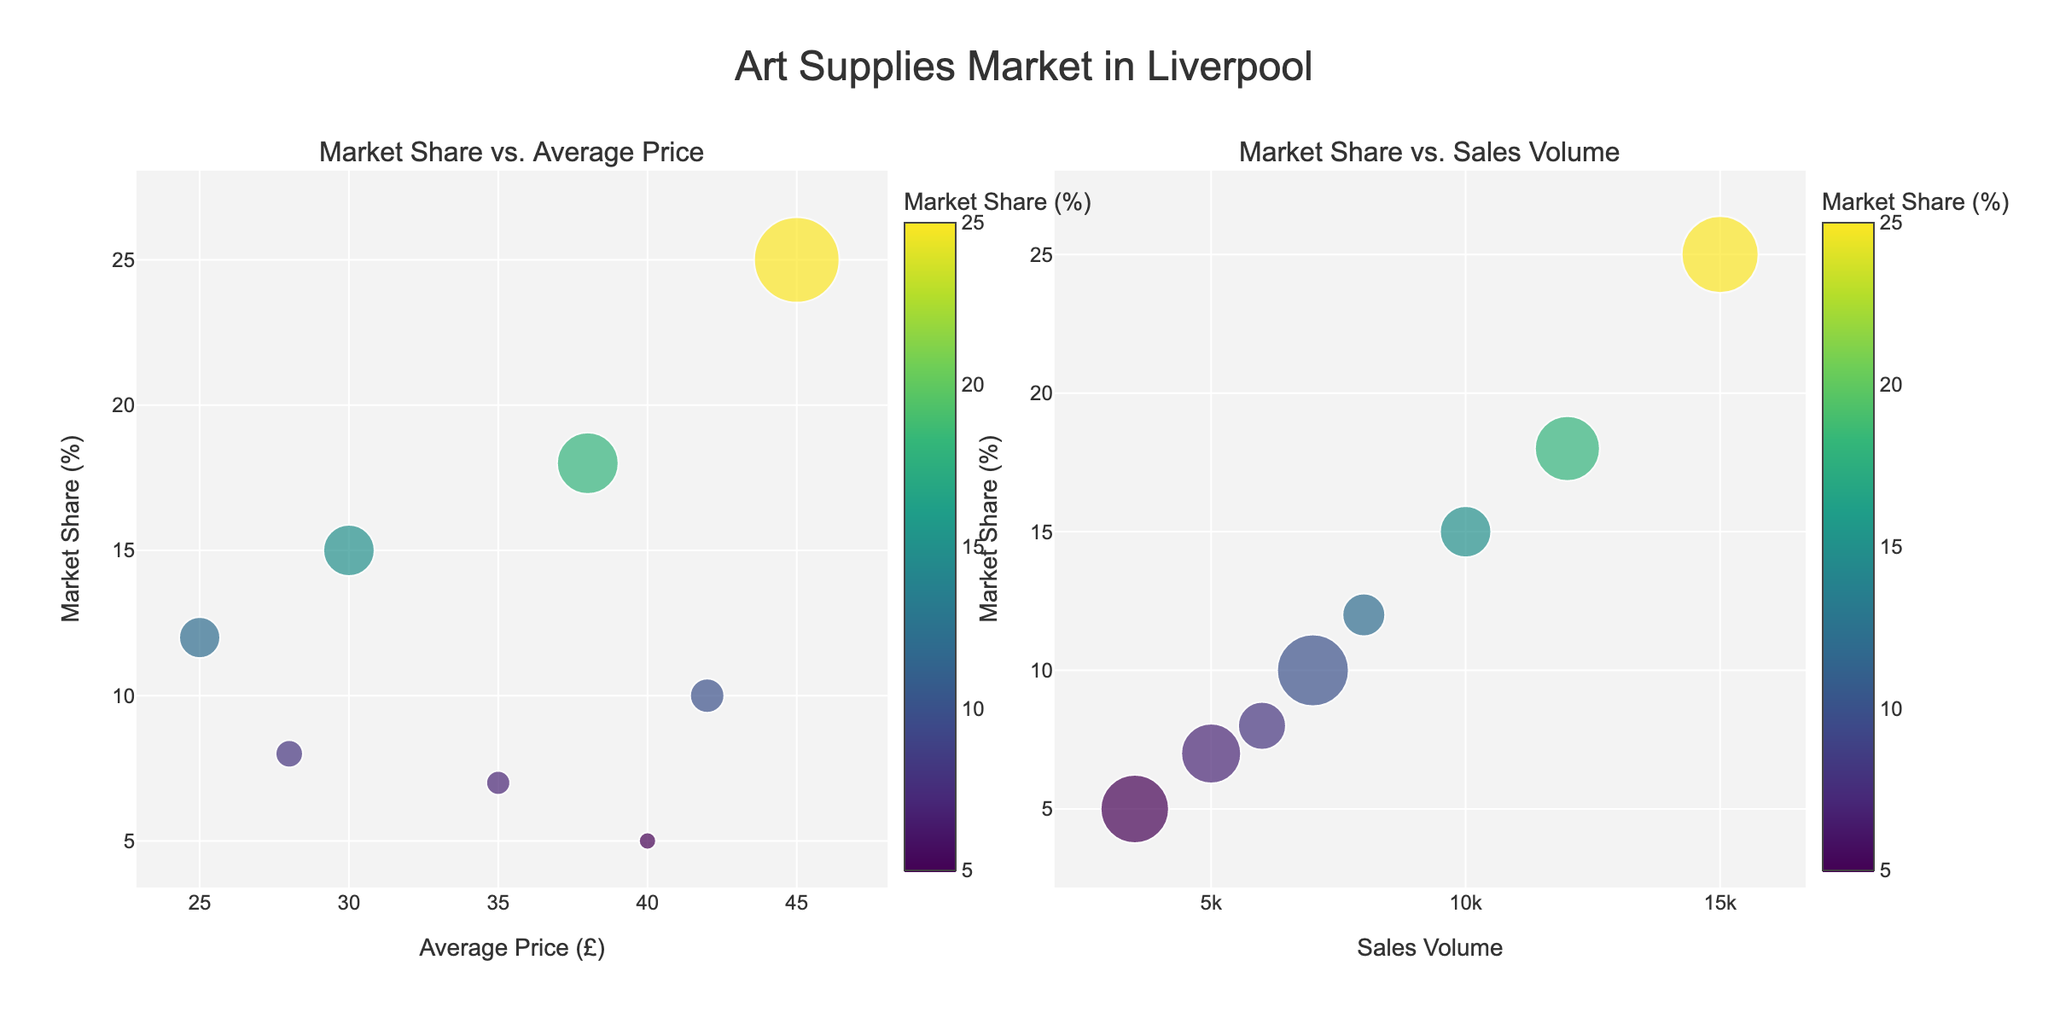What's the title of the figure? At the top of the figure, the title text is displayed prominently.
Answer: Representation of Danish Dialects Across Regions Which region has the highest percentage of Standard Danish? By looking at the pie charts, observe the sections labeled "Standard Danish" in all regions and compare the sizes (percentages).
Answer: Zealand What's the percentage of Copenhagen Danish in Zealand? Focus on the pie chart for the Zealand region and look for the section labeled "Copenhagen Danish" to find the percentage.
Answer: 10% How many regions have Standard Danish as a dialect? Check each pie chart and count the number of regions that include "Standard Danish" as a label in their chart.
Answer: 4 Which region has the most diverse dialect distribution in terms of number of different dialects represented? Observe the number of unique slices in each pie chart, indicating different dialects. Compare the diversity among all regions.
Answer: North Jutland What is the combined percentage of Funen Danish and Standard Danish in Funen? Look at the Funen pie chart, sum the percentages of "Funen Danish" and "Standard Danish" (70% + 30%).
Answer: 100% Compare the percentage of Bornholmsk in Bornholm with Southern Jutland in Jutland. Which one is higher? Check the pie chart for Bornholm for "Bornholmsk" percentage and compare it with the "Southern Jutland" percentage in Jutland.
Answer: Bornholmsk in Bornholm Is North Jutlandic more represented than Vendsyssel Danish in North Jutland? Examine the North Jutland pie chart and compare the percentage of the "North Jutlandic" section to the "Vendsyssel Danish" section.
Answer: Yes What's the total percentage of non-standard Danish dialects in Zealand? Sum the percentages of all non-Standard Danish dialects in the Zealand pie chart (Zealand Danish and Copenhagen Danish).
Answer: 35% Which two regions have only one unique dominant dialect with a percentage of 70% or higher? Identify the regions by checking which pie charts have a single dialect taking 70% or more of the entire pie.
Answer: Funen and Bornholm 